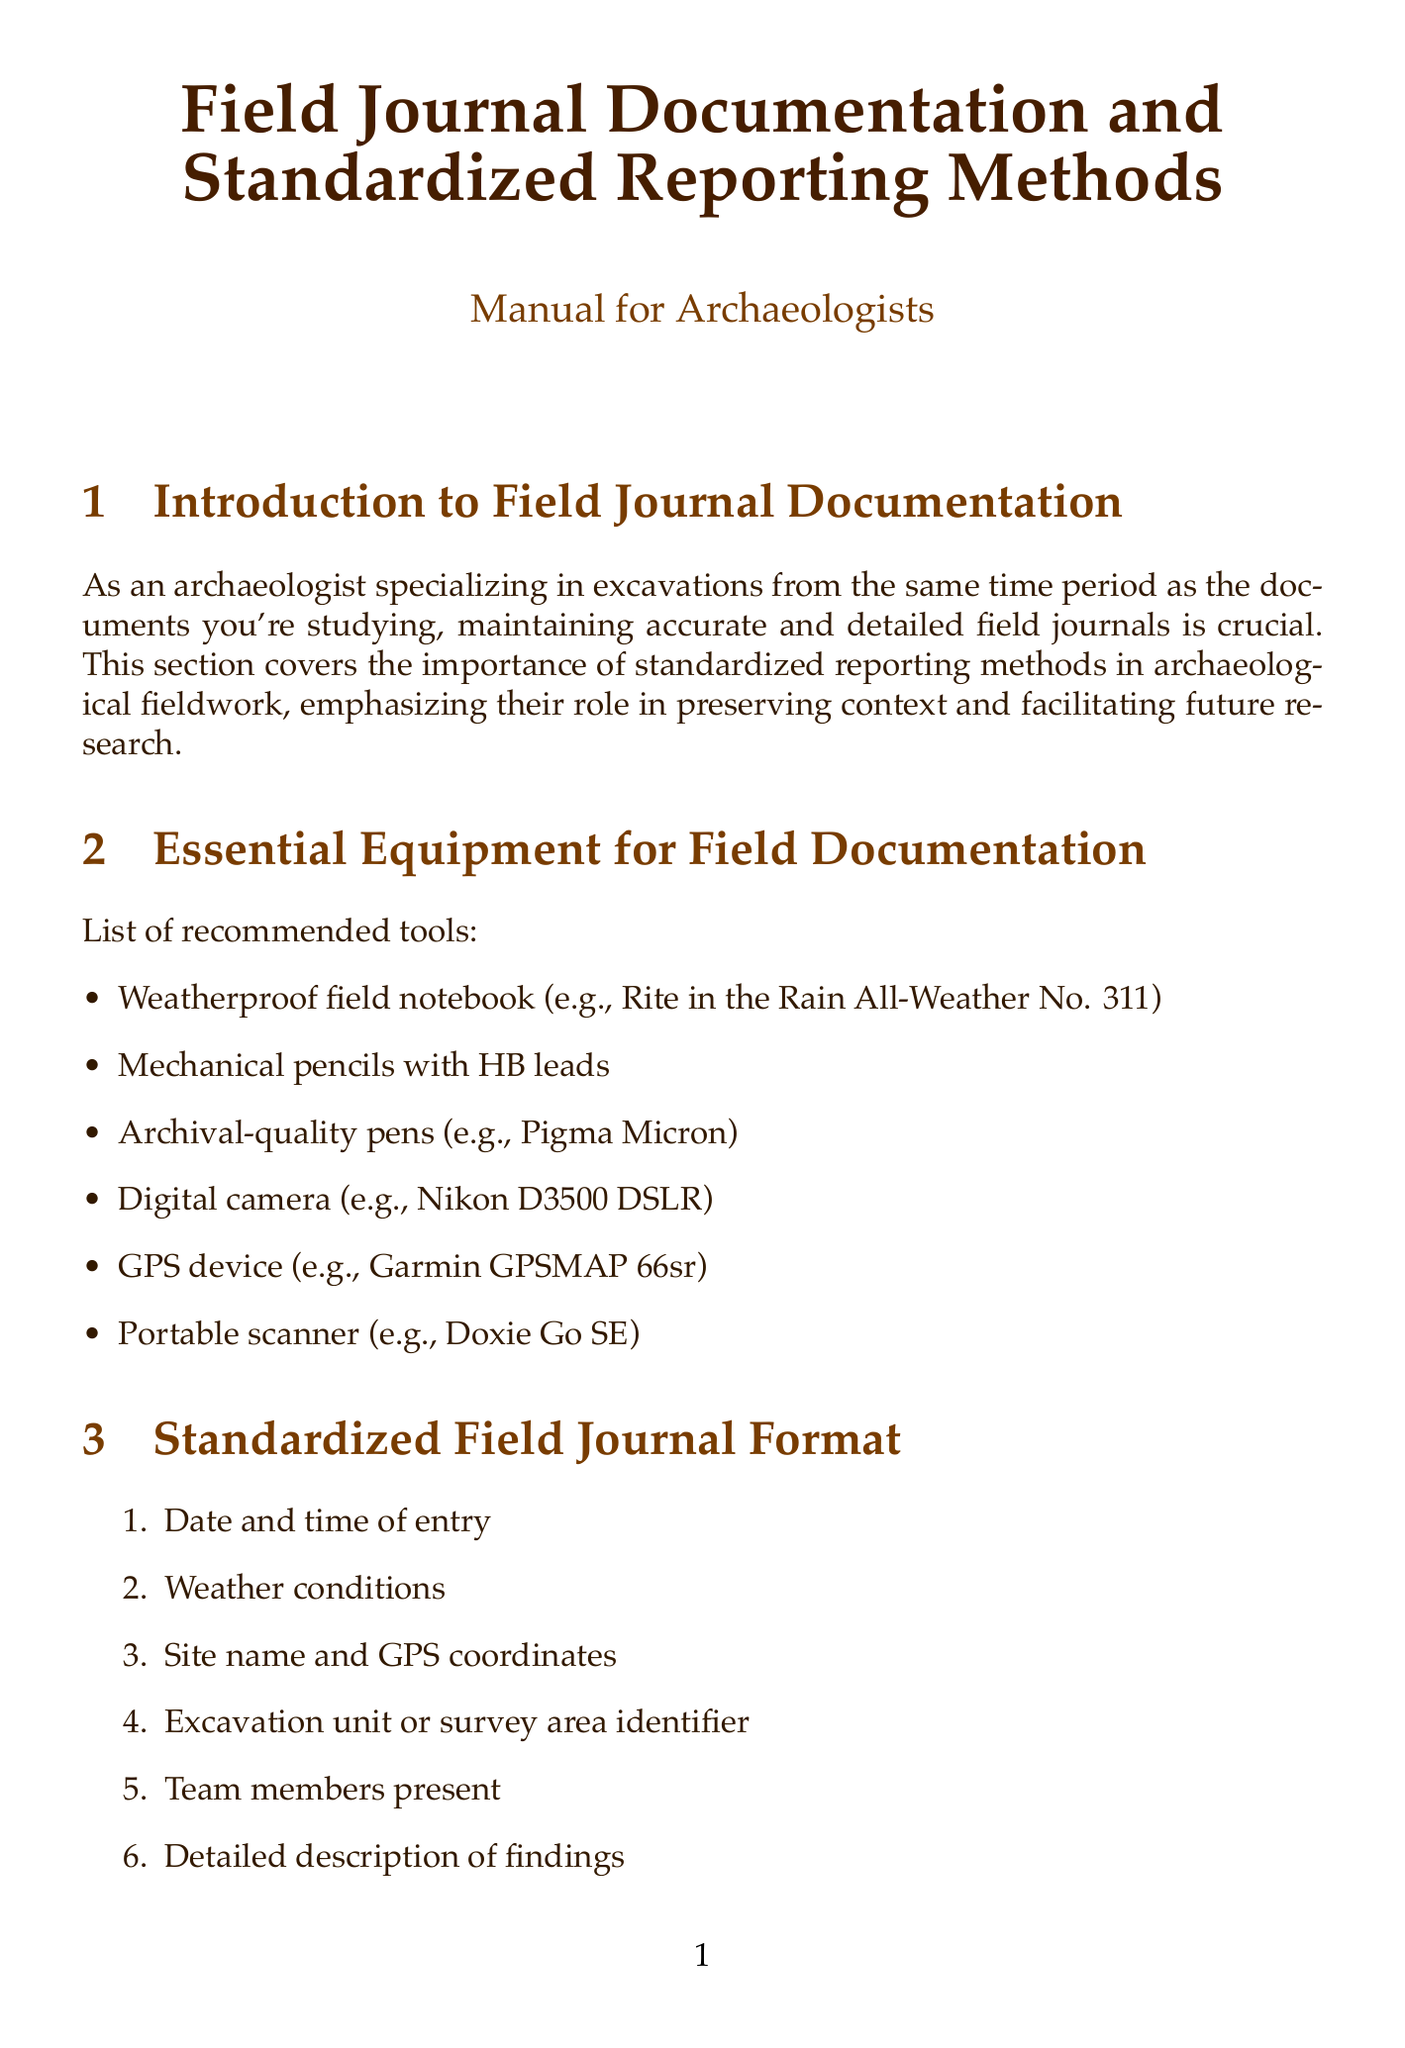What is the title of the manual? The title is stated at the beginning of the document and reflects the main topic covered.
Answer: Field Journal Documentation and Standardized Reporting Methods How many tools are recommended for field documentation? The number of items listed in the essential equipment section indicates the count.
Answer: Six What should always be noted when recording artifacts? This information is specifically mentioned in the section on documenting artifacts in context.
Answer: Precise location Which digital method is suggested for site and artifact modeling? This is mentioned under the digital documentation techniques section as a recommended practice.
Answer: 3D photogrammetry What does the Harris Matrix represent? This concept is introduced in the standardized reporting methods section as a tool for reporting.
Answer: Stratigraphic relationships What is the purpose of scanning handwritten notes? This is explained in the context of preserving and archiving field journals section of the document.
Answer: Long-term preservation What ethical issue is highlighted regarding local communities? The need to respect local communities is mentioned in the ethical considerations section.
Answer: Heritage What common data formats are recommended for collaboration? The document lists specific data formats to promote consistent collaboration.
Answer: CSV, GeoJSON 